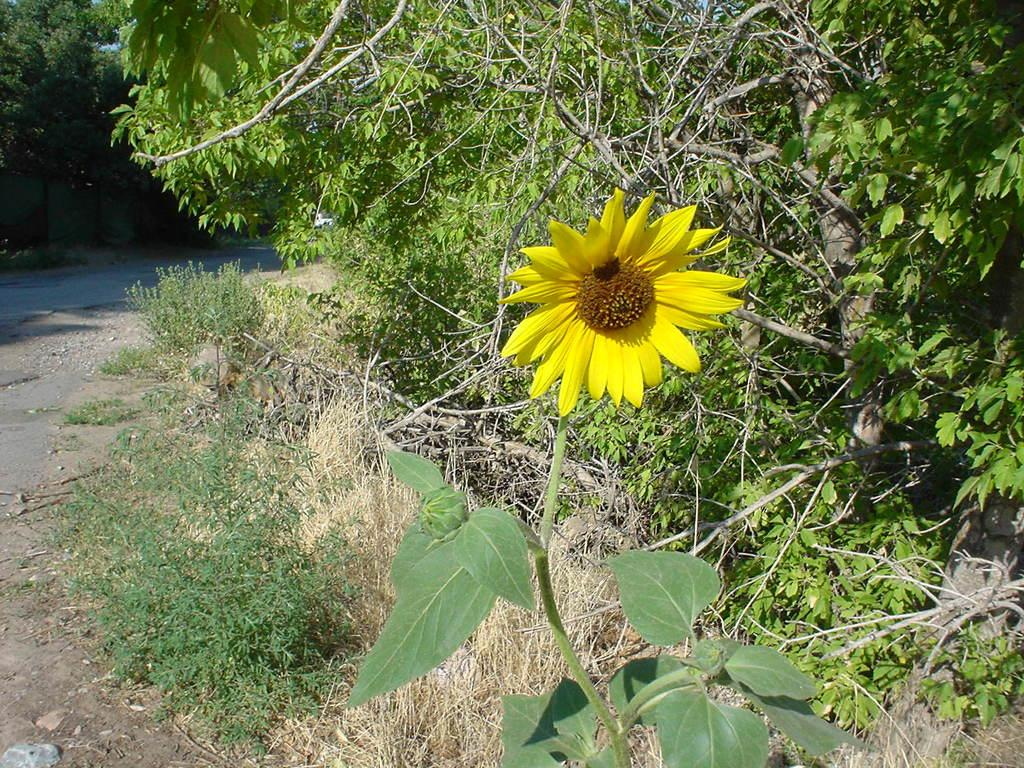What type of plant is in the image? There is a plant with yellow and brown flowers in the image. What is located to the left of the plant? There is a road to the left of the plant. What can be seen near the road? There are many trees near the road. What type of locket is hanging from the tree near the plant? There is no locket present in the image; it only features a plant, a road, and trees. 